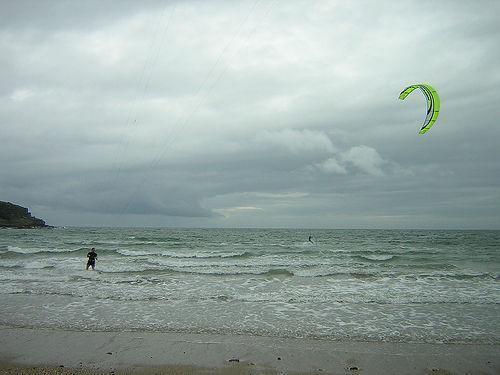How many horses are on the beach?
Give a very brief answer. 0. How many people are in the ocean?
Give a very brief answer. 2. 